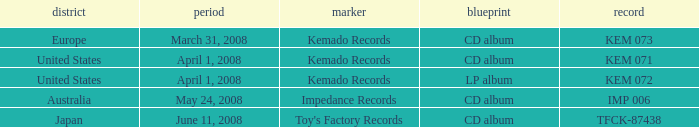Which Format has a Label of toy's factory records? CD album. 